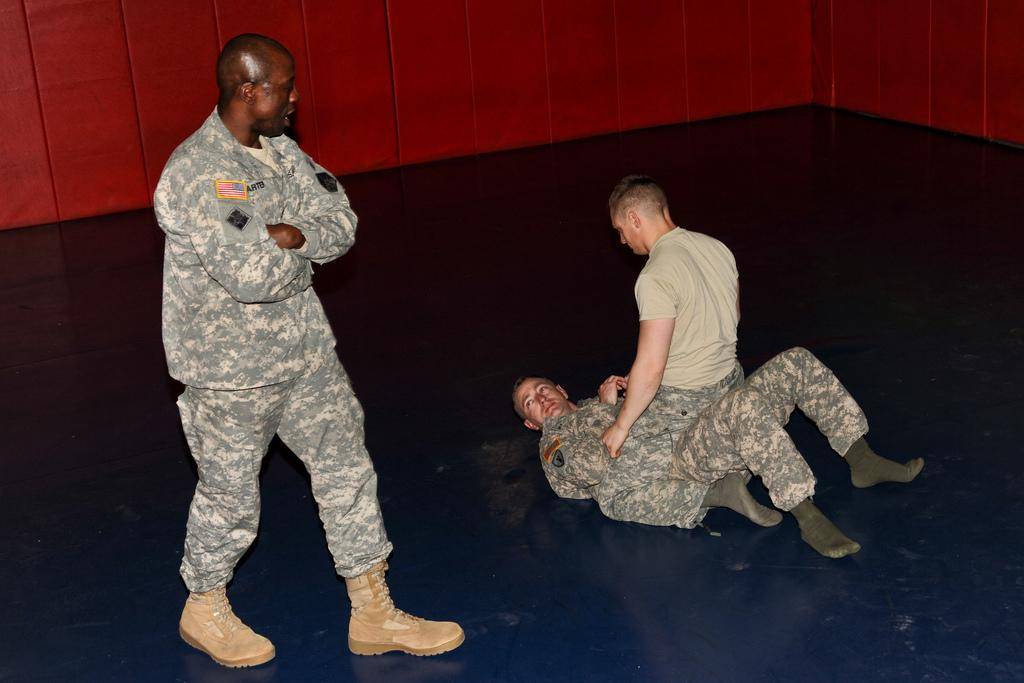How many people are in the image? There are three men in the image. What is the primary surface visible in the image? The image shows a floor. What can be seen in the background of the image? There is a wall in the background of the image. What type of animal can be seen interacting with the men in the image? There are no animals present in the image; it only features three men. What is the source of the oil in the image? There is no oil present in the image. 